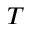<formula> <loc_0><loc_0><loc_500><loc_500>T</formula> 